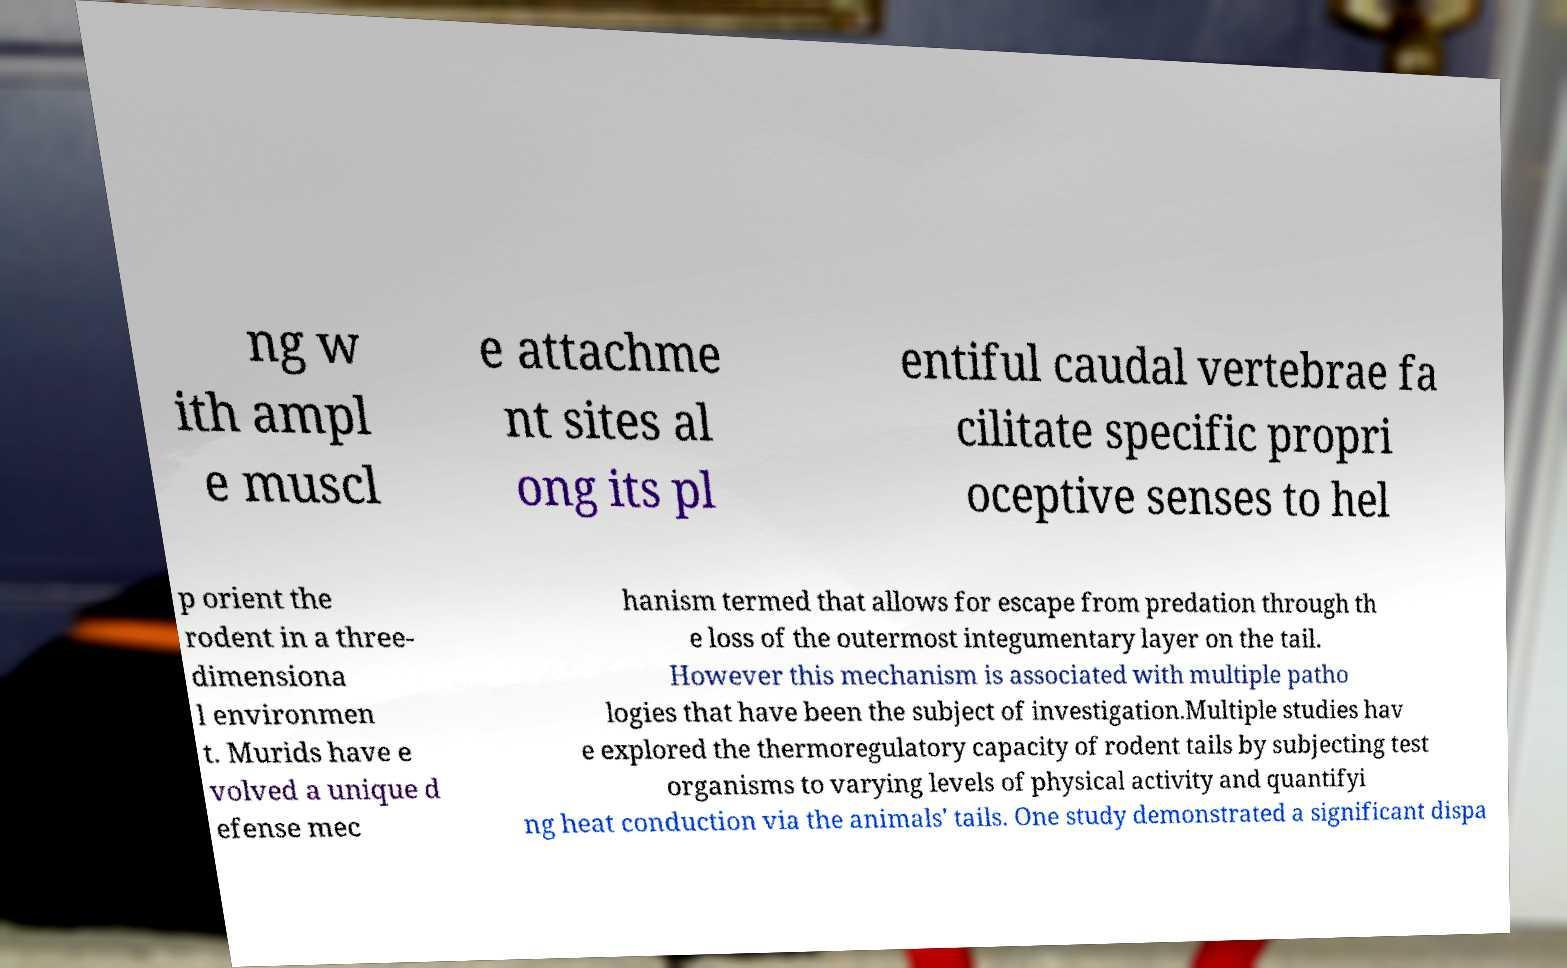What messages or text are displayed in this image? I need them in a readable, typed format. ng w ith ampl e muscl e attachme nt sites al ong its pl entiful caudal vertebrae fa cilitate specific propri oceptive senses to hel p orient the rodent in a three- dimensiona l environmen t. Murids have e volved a unique d efense mec hanism termed that allows for escape from predation through th e loss of the outermost integumentary layer on the tail. However this mechanism is associated with multiple patho logies that have been the subject of investigation.Multiple studies hav e explored the thermoregulatory capacity of rodent tails by subjecting test organisms to varying levels of physical activity and quantifyi ng heat conduction via the animals' tails. One study demonstrated a significant dispa 